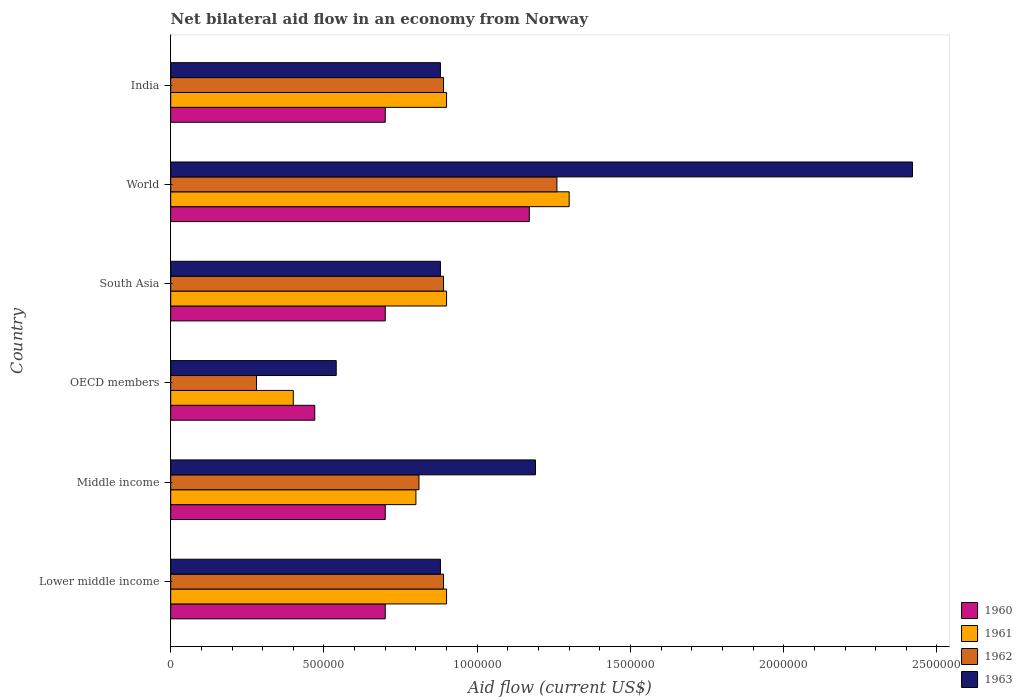How many different coloured bars are there?
Provide a short and direct response. 4. How many groups of bars are there?
Keep it short and to the point. 6. Are the number of bars per tick equal to the number of legend labels?
Your response must be concise. Yes. Are the number of bars on each tick of the Y-axis equal?
Provide a short and direct response. Yes. How many bars are there on the 4th tick from the bottom?
Ensure brevity in your answer.  4. What is the label of the 2nd group of bars from the top?
Offer a very short reply. World. Across all countries, what is the maximum net bilateral aid flow in 1960?
Your answer should be compact. 1.17e+06. Across all countries, what is the minimum net bilateral aid flow in 1960?
Your answer should be compact. 4.70e+05. In which country was the net bilateral aid flow in 1961 minimum?
Offer a terse response. OECD members. What is the total net bilateral aid flow in 1960 in the graph?
Provide a short and direct response. 4.44e+06. What is the difference between the net bilateral aid flow in 1962 in South Asia and the net bilateral aid flow in 1961 in OECD members?
Provide a short and direct response. 4.90e+05. What is the average net bilateral aid flow in 1963 per country?
Your response must be concise. 1.13e+06. What is the difference between the net bilateral aid flow in 1960 and net bilateral aid flow in 1963 in OECD members?
Provide a succinct answer. -7.00e+04. What is the ratio of the net bilateral aid flow in 1961 in India to that in OECD members?
Give a very brief answer. 2.25. Is the difference between the net bilateral aid flow in 1960 in Lower middle income and Middle income greater than the difference between the net bilateral aid flow in 1963 in Lower middle income and Middle income?
Your answer should be compact. Yes. What is the difference between the highest and the lowest net bilateral aid flow in 1963?
Your answer should be very brief. 1.88e+06. In how many countries, is the net bilateral aid flow in 1962 greater than the average net bilateral aid flow in 1962 taken over all countries?
Ensure brevity in your answer.  4. Is the sum of the net bilateral aid flow in 1961 in India and South Asia greater than the maximum net bilateral aid flow in 1960 across all countries?
Provide a succinct answer. Yes. What does the 1st bar from the top in OECD members represents?
Keep it short and to the point. 1963. What does the 1st bar from the bottom in South Asia represents?
Your answer should be very brief. 1960. Is it the case that in every country, the sum of the net bilateral aid flow in 1960 and net bilateral aid flow in 1963 is greater than the net bilateral aid flow in 1962?
Make the answer very short. Yes. What is the difference between two consecutive major ticks on the X-axis?
Make the answer very short. 5.00e+05. Does the graph contain any zero values?
Make the answer very short. No. Does the graph contain grids?
Provide a short and direct response. No. Where does the legend appear in the graph?
Make the answer very short. Bottom right. How many legend labels are there?
Provide a short and direct response. 4. What is the title of the graph?
Make the answer very short. Net bilateral aid flow in an economy from Norway. What is the label or title of the X-axis?
Your answer should be very brief. Aid flow (current US$). What is the Aid flow (current US$) in 1962 in Lower middle income?
Make the answer very short. 8.90e+05. What is the Aid flow (current US$) of 1963 in Lower middle income?
Give a very brief answer. 8.80e+05. What is the Aid flow (current US$) in 1962 in Middle income?
Make the answer very short. 8.10e+05. What is the Aid flow (current US$) of 1963 in Middle income?
Give a very brief answer. 1.19e+06. What is the Aid flow (current US$) in 1960 in OECD members?
Ensure brevity in your answer.  4.70e+05. What is the Aid flow (current US$) in 1961 in OECD members?
Provide a succinct answer. 4.00e+05. What is the Aid flow (current US$) in 1963 in OECD members?
Make the answer very short. 5.40e+05. What is the Aid flow (current US$) of 1961 in South Asia?
Give a very brief answer. 9.00e+05. What is the Aid flow (current US$) of 1962 in South Asia?
Your answer should be compact. 8.90e+05. What is the Aid flow (current US$) of 1963 in South Asia?
Make the answer very short. 8.80e+05. What is the Aid flow (current US$) of 1960 in World?
Give a very brief answer. 1.17e+06. What is the Aid flow (current US$) of 1961 in World?
Ensure brevity in your answer.  1.30e+06. What is the Aid flow (current US$) of 1962 in World?
Give a very brief answer. 1.26e+06. What is the Aid flow (current US$) in 1963 in World?
Make the answer very short. 2.42e+06. What is the Aid flow (current US$) in 1962 in India?
Your response must be concise. 8.90e+05. What is the Aid flow (current US$) of 1963 in India?
Offer a very short reply. 8.80e+05. Across all countries, what is the maximum Aid flow (current US$) of 1960?
Provide a succinct answer. 1.17e+06. Across all countries, what is the maximum Aid flow (current US$) in 1961?
Keep it short and to the point. 1.30e+06. Across all countries, what is the maximum Aid flow (current US$) in 1962?
Keep it short and to the point. 1.26e+06. Across all countries, what is the maximum Aid flow (current US$) in 1963?
Make the answer very short. 2.42e+06. Across all countries, what is the minimum Aid flow (current US$) in 1961?
Your answer should be very brief. 4.00e+05. Across all countries, what is the minimum Aid flow (current US$) of 1963?
Your answer should be compact. 5.40e+05. What is the total Aid flow (current US$) of 1960 in the graph?
Give a very brief answer. 4.44e+06. What is the total Aid flow (current US$) of 1961 in the graph?
Provide a succinct answer. 5.20e+06. What is the total Aid flow (current US$) of 1962 in the graph?
Give a very brief answer. 5.02e+06. What is the total Aid flow (current US$) of 1963 in the graph?
Make the answer very short. 6.79e+06. What is the difference between the Aid flow (current US$) of 1962 in Lower middle income and that in Middle income?
Give a very brief answer. 8.00e+04. What is the difference between the Aid flow (current US$) of 1963 in Lower middle income and that in Middle income?
Make the answer very short. -3.10e+05. What is the difference between the Aid flow (current US$) in 1962 in Lower middle income and that in South Asia?
Your response must be concise. 0. What is the difference between the Aid flow (current US$) of 1963 in Lower middle income and that in South Asia?
Make the answer very short. 0. What is the difference between the Aid flow (current US$) of 1960 in Lower middle income and that in World?
Make the answer very short. -4.70e+05. What is the difference between the Aid flow (current US$) in 1961 in Lower middle income and that in World?
Your answer should be compact. -4.00e+05. What is the difference between the Aid flow (current US$) of 1962 in Lower middle income and that in World?
Offer a terse response. -3.70e+05. What is the difference between the Aid flow (current US$) in 1963 in Lower middle income and that in World?
Provide a short and direct response. -1.54e+06. What is the difference between the Aid flow (current US$) in 1960 in Lower middle income and that in India?
Offer a very short reply. 0. What is the difference between the Aid flow (current US$) of 1961 in Lower middle income and that in India?
Your response must be concise. 0. What is the difference between the Aid flow (current US$) of 1962 in Lower middle income and that in India?
Keep it short and to the point. 0. What is the difference between the Aid flow (current US$) of 1960 in Middle income and that in OECD members?
Your answer should be very brief. 2.30e+05. What is the difference between the Aid flow (current US$) of 1961 in Middle income and that in OECD members?
Provide a short and direct response. 4.00e+05. What is the difference between the Aid flow (current US$) in 1962 in Middle income and that in OECD members?
Your answer should be very brief. 5.30e+05. What is the difference between the Aid flow (current US$) in 1963 in Middle income and that in OECD members?
Your response must be concise. 6.50e+05. What is the difference between the Aid flow (current US$) in 1960 in Middle income and that in South Asia?
Keep it short and to the point. 0. What is the difference between the Aid flow (current US$) of 1963 in Middle income and that in South Asia?
Make the answer very short. 3.10e+05. What is the difference between the Aid flow (current US$) in 1960 in Middle income and that in World?
Offer a very short reply. -4.70e+05. What is the difference between the Aid flow (current US$) in 1961 in Middle income and that in World?
Offer a very short reply. -5.00e+05. What is the difference between the Aid flow (current US$) of 1962 in Middle income and that in World?
Offer a very short reply. -4.50e+05. What is the difference between the Aid flow (current US$) of 1963 in Middle income and that in World?
Your response must be concise. -1.23e+06. What is the difference between the Aid flow (current US$) of 1960 in Middle income and that in India?
Provide a succinct answer. 0. What is the difference between the Aid flow (current US$) in 1961 in Middle income and that in India?
Make the answer very short. -1.00e+05. What is the difference between the Aid flow (current US$) in 1963 in Middle income and that in India?
Provide a succinct answer. 3.10e+05. What is the difference between the Aid flow (current US$) of 1960 in OECD members and that in South Asia?
Provide a succinct answer. -2.30e+05. What is the difference between the Aid flow (current US$) of 1961 in OECD members and that in South Asia?
Your answer should be very brief. -5.00e+05. What is the difference between the Aid flow (current US$) in 1962 in OECD members and that in South Asia?
Your answer should be compact. -6.10e+05. What is the difference between the Aid flow (current US$) of 1963 in OECD members and that in South Asia?
Your answer should be very brief. -3.40e+05. What is the difference between the Aid flow (current US$) in 1960 in OECD members and that in World?
Your answer should be very brief. -7.00e+05. What is the difference between the Aid flow (current US$) of 1961 in OECD members and that in World?
Your answer should be very brief. -9.00e+05. What is the difference between the Aid flow (current US$) of 1962 in OECD members and that in World?
Ensure brevity in your answer.  -9.80e+05. What is the difference between the Aid flow (current US$) of 1963 in OECD members and that in World?
Make the answer very short. -1.88e+06. What is the difference between the Aid flow (current US$) of 1961 in OECD members and that in India?
Give a very brief answer. -5.00e+05. What is the difference between the Aid flow (current US$) in 1962 in OECD members and that in India?
Provide a short and direct response. -6.10e+05. What is the difference between the Aid flow (current US$) in 1960 in South Asia and that in World?
Give a very brief answer. -4.70e+05. What is the difference between the Aid flow (current US$) in 1961 in South Asia and that in World?
Keep it short and to the point. -4.00e+05. What is the difference between the Aid flow (current US$) of 1962 in South Asia and that in World?
Offer a very short reply. -3.70e+05. What is the difference between the Aid flow (current US$) in 1963 in South Asia and that in World?
Give a very brief answer. -1.54e+06. What is the difference between the Aid flow (current US$) of 1960 in South Asia and that in India?
Offer a terse response. 0. What is the difference between the Aid flow (current US$) in 1962 in South Asia and that in India?
Offer a terse response. 0. What is the difference between the Aid flow (current US$) in 1963 in South Asia and that in India?
Give a very brief answer. 0. What is the difference between the Aid flow (current US$) in 1960 in World and that in India?
Give a very brief answer. 4.70e+05. What is the difference between the Aid flow (current US$) in 1961 in World and that in India?
Offer a terse response. 4.00e+05. What is the difference between the Aid flow (current US$) of 1963 in World and that in India?
Ensure brevity in your answer.  1.54e+06. What is the difference between the Aid flow (current US$) of 1960 in Lower middle income and the Aid flow (current US$) of 1962 in Middle income?
Ensure brevity in your answer.  -1.10e+05. What is the difference between the Aid flow (current US$) in 1960 in Lower middle income and the Aid flow (current US$) in 1963 in Middle income?
Ensure brevity in your answer.  -4.90e+05. What is the difference between the Aid flow (current US$) in 1962 in Lower middle income and the Aid flow (current US$) in 1963 in Middle income?
Your answer should be compact. -3.00e+05. What is the difference between the Aid flow (current US$) of 1960 in Lower middle income and the Aid flow (current US$) of 1961 in OECD members?
Your answer should be compact. 3.00e+05. What is the difference between the Aid flow (current US$) in 1960 in Lower middle income and the Aid flow (current US$) in 1962 in OECD members?
Make the answer very short. 4.20e+05. What is the difference between the Aid flow (current US$) in 1960 in Lower middle income and the Aid flow (current US$) in 1963 in OECD members?
Offer a very short reply. 1.60e+05. What is the difference between the Aid flow (current US$) of 1961 in Lower middle income and the Aid flow (current US$) of 1962 in OECD members?
Your answer should be compact. 6.20e+05. What is the difference between the Aid flow (current US$) of 1962 in Lower middle income and the Aid flow (current US$) of 1963 in OECD members?
Your answer should be very brief. 3.50e+05. What is the difference between the Aid flow (current US$) of 1960 in Lower middle income and the Aid flow (current US$) of 1961 in South Asia?
Offer a very short reply. -2.00e+05. What is the difference between the Aid flow (current US$) of 1960 in Lower middle income and the Aid flow (current US$) of 1963 in South Asia?
Make the answer very short. -1.80e+05. What is the difference between the Aid flow (current US$) in 1961 in Lower middle income and the Aid flow (current US$) in 1963 in South Asia?
Give a very brief answer. 2.00e+04. What is the difference between the Aid flow (current US$) of 1962 in Lower middle income and the Aid flow (current US$) of 1963 in South Asia?
Give a very brief answer. 10000. What is the difference between the Aid flow (current US$) in 1960 in Lower middle income and the Aid flow (current US$) in 1961 in World?
Provide a succinct answer. -6.00e+05. What is the difference between the Aid flow (current US$) in 1960 in Lower middle income and the Aid flow (current US$) in 1962 in World?
Make the answer very short. -5.60e+05. What is the difference between the Aid flow (current US$) in 1960 in Lower middle income and the Aid flow (current US$) in 1963 in World?
Provide a short and direct response. -1.72e+06. What is the difference between the Aid flow (current US$) in 1961 in Lower middle income and the Aid flow (current US$) in 1962 in World?
Ensure brevity in your answer.  -3.60e+05. What is the difference between the Aid flow (current US$) in 1961 in Lower middle income and the Aid flow (current US$) in 1963 in World?
Make the answer very short. -1.52e+06. What is the difference between the Aid flow (current US$) in 1962 in Lower middle income and the Aid flow (current US$) in 1963 in World?
Ensure brevity in your answer.  -1.53e+06. What is the difference between the Aid flow (current US$) in 1960 in Lower middle income and the Aid flow (current US$) in 1962 in India?
Make the answer very short. -1.90e+05. What is the difference between the Aid flow (current US$) of 1961 in Lower middle income and the Aid flow (current US$) of 1963 in India?
Give a very brief answer. 2.00e+04. What is the difference between the Aid flow (current US$) of 1962 in Lower middle income and the Aid flow (current US$) of 1963 in India?
Your answer should be very brief. 10000. What is the difference between the Aid flow (current US$) of 1960 in Middle income and the Aid flow (current US$) of 1961 in OECD members?
Ensure brevity in your answer.  3.00e+05. What is the difference between the Aid flow (current US$) in 1961 in Middle income and the Aid flow (current US$) in 1962 in OECD members?
Offer a very short reply. 5.20e+05. What is the difference between the Aid flow (current US$) of 1960 in Middle income and the Aid flow (current US$) of 1963 in South Asia?
Give a very brief answer. -1.80e+05. What is the difference between the Aid flow (current US$) in 1961 in Middle income and the Aid flow (current US$) in 1963 in South Asia?
Make the answer very short. -8.00e+04. What is the difference between the Aid flow (current US$) of 1960 in Middle income and the Aid flow (current US$) of 1961 in World?
Ensure brevity in your answer.  -6.00e+05. What is the difference between the Aid flow (current US$) in 1960 in Middle income and the Aid flow (current US$) in 1962 in World?
Offer a very short reply. -5.60e+05. What is the difference between the Aid flow (current US$) of 1960 in Middle income and the Aid flow (current US$) of 1963 in World?
Ensure brevity in your answer.  -1.72e+06. What is the difference between the Aid flow (current US$) of 1961 in Middle income and the Aid flow (current US$) of 1962 in World?
Offer a very short reply. -4.60e+05. What is the difference between the Aid flow (current US$) in 1961 in Middle income and the Aid flow (current US$) in 1963 in World?
Make the answer very short. -1.62e+06. What is the difference between the Aid flow (current US$) of 1962 in Middle income and the Aid flow (current US$) of 1963 in World?
Provide a succinct answer. -1.61e+06. What is the difference between the Aid flow (current US$) in 1960 in Middle income and the Aid flow (current US$) in 1961 in India?
Provide a succinct answer. -2.00e+05. What is the difference between the Aid flow (current US$) of 1961 in Middle income and the Aid flow (current US$) of 1962 in India?
Offer a terse response. -9.00e+04. What is the difference between the Aid flow (current US$) of 1960 in OECD members and the Aid flow (current US$) of 1961 in South Asia?
Provide a succinct answer. -4.30e+05. What is the difference between the Aid flow (current US$) in 1960 in OECD members and the Aid flow (current US$) in 1962 in South Asia?
Your answer should be compact. -4.20e+05. What is the difference between the Aid flow (current US$) in 1960 in OECD members and the Aid flow (current US$) in 1963 in South Asia?
Your answer should be compact. -4.10e+05. What is the difference between the Aid flow (current US$) in 1961 in OECD members and the Aid flow (current US$) in 1962 in South Asia?
Your response must be concise. -4.90e+05. What is the difference between the Aid flow (current US$) in 1961 in OECD members and the Aid flow (current US$) in 1963 in South Asia?
Offer a very short reply. -4.80e+05. What is the difference between the Aid flow (current US$) of 1962 in OECD members and the Aid flow (current US$) of 1963 in South Asia?
Provide a succinct answer. -6.00e+05. What is the difference between the Aid flow (current US$) in 1960 in OECD members and the Aid flow (current US$) in 1961 in World?
Your answer should be compact. -8.30e+05. What is the difference between the Aid flow (current US$) of 1960 in OECD members and the Aid flow (current US$) of 1962 in World?
Provide a short and direct response. -7.90e+05. What is the difference between the Aid flow (current US$) of 1960 in OECD members and the Aid flow (current US$) of 1963 in World?
Give a very brief answer. -1.95e+06. What is the difference between the Aid flow (current US$) in 1961 in OECD members and the Aid flow (current US$) in 1962 in World?
Ensure brevity in your answer.  -8.60e+05. What is the difference between the Aid flow (current US$) in 1961 in OECD members and the Aid flow (current US$) in 1963 in World?
Provide a short and direct response. -2.02e+06. What is the difference between the Aid flow (current US$) in 1962 in OECD members and the Aid flow (current US$) in 1963 in World?
Ensure brevity in your answer.  -2.14e+06. What is the difference between the Aid flow (current US$) of 1960 in OECD members and the Aid flow (current US$) of 1961 in India?
Give a very brief answer. -4.30e+05. What is the difference between the Aid flow (current US$) in 1960 in OECD members and the Aid flow (current US$) in 1962 in India?
Provide a short and direct response. -4.20e+05. What is the difference between the Aid flow (current US$) of 1960 in OECD members and the Aid flow (current US$) of 1963 in India?
Ensure brevity in your answer.  -4.10e+05. What is the difference between the Aid flow (current US$) in 1961 in OECD members and the Aid flow (current US$) in 1962 in India?
Ensure brevity in your answer.  -4.90e+05. What is the difference between the Aid flow (current US$) in 1961 in OECD members and the Aid flow (current US$) in 1963 in India?
Provide a short and direct response. -4.80e+05. What is the difference between the Aid flow (current US$) in 1962 in OECD members and the Aid flow (current US$) in 1963 in India?
Provide a short and direct response. -6.00e+05. What is the difference between the Aid flow (current US$) in 1960 in South Asia and the Aid flow (current US$) in 1961 in World?
Your response must be concise. -6.00e+05. What is the difference between the Aid flow (current US$) in 1960 in South Asia and the Aid flow (current US$) in 1962 in World?
Offer a terse response. -5.60e+05. What is the difference between the Aid flow (current US$) in 1960 in South Asia and the Aid flow (current US$) in 1963 in World?
Make the answer very short. -1.72e+06. What is the difference between the Aid flow (current US$) of 1961 in South Asia and the Aid flow (current US$) of 1962 in World?
Make the answer very short. -3.60e+05. What is the difference between the Aid flow (current US$) of 1961 in South Asia and the Aid flow (current US$) of 1963 in World?
Offer a terse response. -1.52e+06. What is the difference between the Aid flow (current US$) in 1962 in South Asia and the Aid flow (current US$) in 1963 in World?
Your answer should be compact. -1.53e+06. What is the difference between the Aid flow (current US$) in 1960 in South Asia and the Aid flow (current US$) in 1962 in India?
Offer a very short reply. -1.90e+05. What is the difference between the Aid flow (current US$) of 1960 in South Asia and the Aid flow (current US$) of 1963 in India?
Offer a terse response. -1.80e+05. What is the difference between the Aid flow (current US$) of 1961 in South Asia and the Aid flow (current US$) of 1962 in India?
Provide a short and direct response. 10000. What is the difference between the Aid flow (current US$) in 1961 in South Asia and the Aid flow (current US$) in 1963 in India?
Ensure brevity in your answer.  2.00e+04. What is the difference between the Aid flow (current US$) in 1962 in World and the Aid flow (current US$) in 1963 in India?
Offer a very short reply. 3.80e+05. What is the average Aid flow (current US$) of 1960 per country?
Give a very brief answer. 7.40e+05. What is the average Aid flow (current US$) of 1961 per country?
Keep it short and to the point. 8.67e+05. What is the average Aid flow (current US$) in 1962 per country?
Your response must be concise. 8.37e+05. What is the average Aid flow (current US$) in 1963 per country?
Keep it short and to the point. 1.13e+06. What is the difference between the Aid flow (current US$) in 1960 and Aid flow (current US$) in 1961 in Lower middle income?
Keep it short and to the point. -2.00e+05. What is the difference between the Aid flow (current US$) in 1960 and Aid flow (current US$) in 1962 in Lower middle income?
Offer a terse response. -1.90e+05. What is the difference between the Aid flow (current US$) in 1961 and Aid flow (current US$) in 1963 in Lower middle income?
Provide a succinct answer. 2.00e+04. What is the difference between the Aid flow (current US$) in 1960 and Aid flow (current US$) in 1962 in Middle income?
Provide a short and direct response. -1.10e+05. What is the difference between the Aid flow (current US$) of 1960 and Aid flow (current US$) of 1963 in Middle income?
Provide a succinct answer. -4.90e+05. What is the difference between the Aid flow (current US$) in 1961 and Aid flow (current US$) in 1963 in Middle income?
Your response must be concise. -3.90e+05. What is the difference between the Aid flow (current US$) of 1962 and Aid flow (current US$) of 1963 in Middle income?
Your response must be concise. -3.80e+05. What is the difference between the Aid flow (current US$) in 1962 and Aid flow (current US$) in 1963 in OECD members?
Your answer should be very brief. -2.60e+05. What is the difference between the Aid flow (current US$) in 1960 and Aid flow (current US$) in 1961 in South Asia?
Your response must be concise. -2.00e+05. What is the difference between the Aid flow (current US$) in 1960 and Aid flow (current US$) in 1963 in South Asia?
Provide a short and direct response. -1.80e+05. What is the difference between the Aid flow (current US$) in 1961 and Aid flow (current US$) in 1962 in South Asia?
Ensure brevity in your answer.  10000. What is the difference between the Aid flow (current US$) of 1962 and Aid flow (current US$) of 1963 in South Asia?
Ensure brevity in your answer.  10000. What is the difference between the Aid flow (current US$) in 1960 and Aid flow (current US$) in 1963 in World?
Provide a short and direct response. -1.25e+06. What is the difference between the Aid flow (current US$) in 1961 and Aid flow (current US$) in 1963 in World?
Your answer should be compact. -1.12e+06. What is the difference between the Aid flow (current US$) of 1962 and Aid flow (current US$) of 1963 in World?
Ensure brevity in your answer.  -1.16e+06. What is the difference between the Aid flow (current US$) in 1960 and Aid flow (current US$) in 1961 in India?
Offer a very short reply. -2.00e+05. What is the difference between the Aid flow (current US$) of 1960 and Aid flow (current US$) of 1962 in India?
Your response must be concise. -1.90e+05. What is the difference between the Aid flow (current US$) in 1960 and Aid flow (current US$) in 1963 in India?
Make the answer very short. -1.80e+05. What is the difference between the Aid flow (current US$) in 1962 and Aid flow (current US$) in 1963 in India?
Your response must be concise. 10000. What is the ratio of the Aid flow (current US$) in 1960 in Lower middle income to that in Middle income?
Offer a terse response. 1. What is the ratio of the Aid flow (current US$) of 1962 in Lower middle income to that in Middle income?
Your answer should be very brief. 1.1. What is the ratio of the Aid flow (current US$) in 1963 in Lower middle income to that in Middle income?
Give a very brief answer. 0.74. What is the ratio of the Aid flow (current US$) of 1960 in Lower middle income to that in OECD members?
Ensure brevity in your answer.  1.49. What is the ratio of the Aid flow (current US$) of 1961 in Lower middle income to that in OECD members?
Your response must be concise. 2.25. What is the ratio of the Aid flow (current US$) of 1962 in Lower middle income to that in OECD members?
Provide a short and direct response. 3.18. What is the ratio of the Aid flow (current US$) of 1963 in Lower middle income to that in OECD members?
Your response must be concise. 1.63. What is the ratio of the Aid flow (current US$) in 1960 in Lower middle income to that in South Asia?
Your response must be concise. 1. What is the ratio of the Aid flow (current US$) in 1961 in Lower middle income to that in South Asia?
Offer a terse response. 1. What is the ratio of the Aid flow (current US$) of 1960 in Lower middle income to that in World?
Keep it short and to the point. 0.6. What is the ratio of the Aid flow (current US$) of 1961 in Lower middle income to that in World?
Your answer should be very brief. 0.69. What is the ratio of the Aid flow (current US$) of 1962 in Lower middle income to that in World?
Your answer should be very brief. 0.71. What is the ratio of the Aid flow (current US$) in 1963 in Lower middle income to that in World?
Your answer should be compact. 0.36. What is the ratio of the Aid flow (current US$) in 1960 in Middle income to that in OECD members?
Offer a terse response. 1.49. What is the ratio of the Aid flow (current US$) of 1962 in Middle income to that in OECD members?
Your response must be concise. 2.89. What is the ratio of the Aid flow (current US$) of 1963 in Middle income to that in OECD members?
Offer a very short reply. 2.2. What is the ratio of the Aid flow (current US$) in 1960 in Middle income to that in South Asia?
Your answer should be very brief. 1. What is the ratio of the Aid flow (current US$) in 1961 in Middle income to that in South Asia?
Make the answer very short. 0.89. What is the ratio of the Aid flow (current US$) of 1962 in Middle income to that in South Asia?
Offer a terse response. 0.91. What is the ratio of the Aid flow (current US$) in 1963 in Middle income to that in South Asia?
Make the answer very short. 1.35. What is the ratio of the Aid flow (current US$) of 1960 in Middle income to that in World?
Give a very brief answer. 0.6. What is the ratio of the Aid flow (current US$) in 1961 in Middle income to that in World?
Make the answer very short. 0.62. What is the ratio of the Aid flow (current US$) of 1962 in Middle income to that in World?
Make the answer very short. 0.64. What is the ratio of the Aid flow (current US$) of 1963 in Middle income to that in World?
Give a very brief answer. 0.49. What is the ratio of the Aid flow (current US$) in 1960 in Middle income to that in India?
Your answer should be very brief. 1. What is the ratio of the Aid flow (current US$) in 1962 in Middle income to that in India?
Make the answer very short. 0.91. What is the ratio of the Aid flow (current US$) of 1963 in Middle income to that in India?
Offer a terse response. 1.35. What is the ratio of the Aid flow (current US$) in 1960 in OECD members to that in South Asia?
Offer a terse response. 0.67. What is the ratio of the Aid flow (current US$) in 1961 in OECD members to that in South Asia?
Provide a succinct answer. 0.44. What is the ratio of the Aid flow (current US$) of 1962 in OECD members to that in South Asia?
Your answer should be very brief. 0.31. What is the ratio of the Aid flow (current US$) in 1963 in OECD members to that in South Asia?
Make the answer very short. 0.61. What is the ratio of the Aid flow (current US$) in 1960 in OECD members to that in World?
Keep it short and to the point. 0.4. What is the ratio of the Aid flow (current US$) of 1961 in OECD members to that in World?
Ensure brevity in your answer.  0.31. What is the ratio of the Aid flow (current US$) in 1962 in OECD members to that in World?
Your answer should be compact. 0.22. What is the ratio of the Aid flow (current US$) in 1963 in OECD members to that in World?
Offer a very short reply. 0.22. What is the ratio of the Aid flow (current US$) of 1960 in OECD members to that in India?
Offer a very short reply. 0.67. What is the ratio of the Aid flow (current US$) in 1961 in OECD members to that in India?
Offer a terse response. 0.44. What is the ratio of the Aid flow (current US$) of 1962 in OECD members to that in India?
Keep it short and to the point. 0.31. What is the ratio of the Aid flow (current US$) of 1963 in OECD members to that in India?
Provide a short and direct response. 0.61. What is the ratio of the Aid flow (current US$) in 1960 in South Asia to that in World?
Give a very brief answer. 0.6. What is the ratio of the Aid flow (current US$) in 1961 in South Asia to that in World?
Your answer should be compact. 0.69. What is the ratio of the Aid flow (current US$) of 1962 in South Asia to that in World?
Your response must be concise. 0.71. What is the ratio of the Aid flow (current US$) in 1963 in South Asia to that in World?
Your response must be concise. 0.36. What is the ratio of the Aid flow (current US$) of 1960 in South Asia to that in India?
Your response must be concise. 1. What is the ratio of the Aid flow (current US$) in 1962 in South Asia to that in India?
Your answer should be very brief. 1. What is the ratio of the Aid flow (current US$) of 1963 in South Asia to that in India?
Provide a short and direct response. 1. What is the ratio of the Aid flow (current US$) of 1960 in World to that in India?
Offer a terse response. 1.67. What is the ratio of the Aid flow (current US$) in 1961 in World to that in India?
Your response must be concise. 1.44. What is the ratio of the Aid flow (current US$) of 1962 in World to that in India?
Your answer should be compact. 1.42. What is the ratio of the Aid flow (current US$) in 1963 in World to that in India?
Provide a short and direct response. 2.75. What is the difference between the highest and the second highest Aid flow (current US$) in 1960?
Give a very brief answer. 4.70e+05. What is the difference between the highest and the second highest Aid flow (current US$) in 1962?
Your answer should be compact. 3.70e+05. What is the difference between the highest and the second highest Aid flow (current US$) of 1963?
Provide a short and direct response. 1.23e+06. What is the difference between the highest and the lowest Aid flow (current US$) in 1960?
Provide a short and direct response. 7.00e+05. What is the difference between the highest and the lowest Aid flow (current US$) in 1961?
Provide a succinct answer. 9.00e+05. What is the difference between the highest and the lowest Aid flow (current US$) in 1962?
Your response must be concise. 9.80e+05. What is the difference between the highest and the lowest Aid flow (current US$) of 1963?
Offer a very short reply. 1.88e+06. 